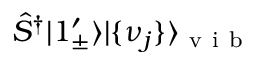Convert formula to latex. <formula><loc_0><loc_0><loc_500><loc_500>\hat { S } ^ { \dagger } | 1 _ { \pm } ^ { \prime } \rangle | \{ \nu _ { j } \} \rangle _ { v i b }</formula> 